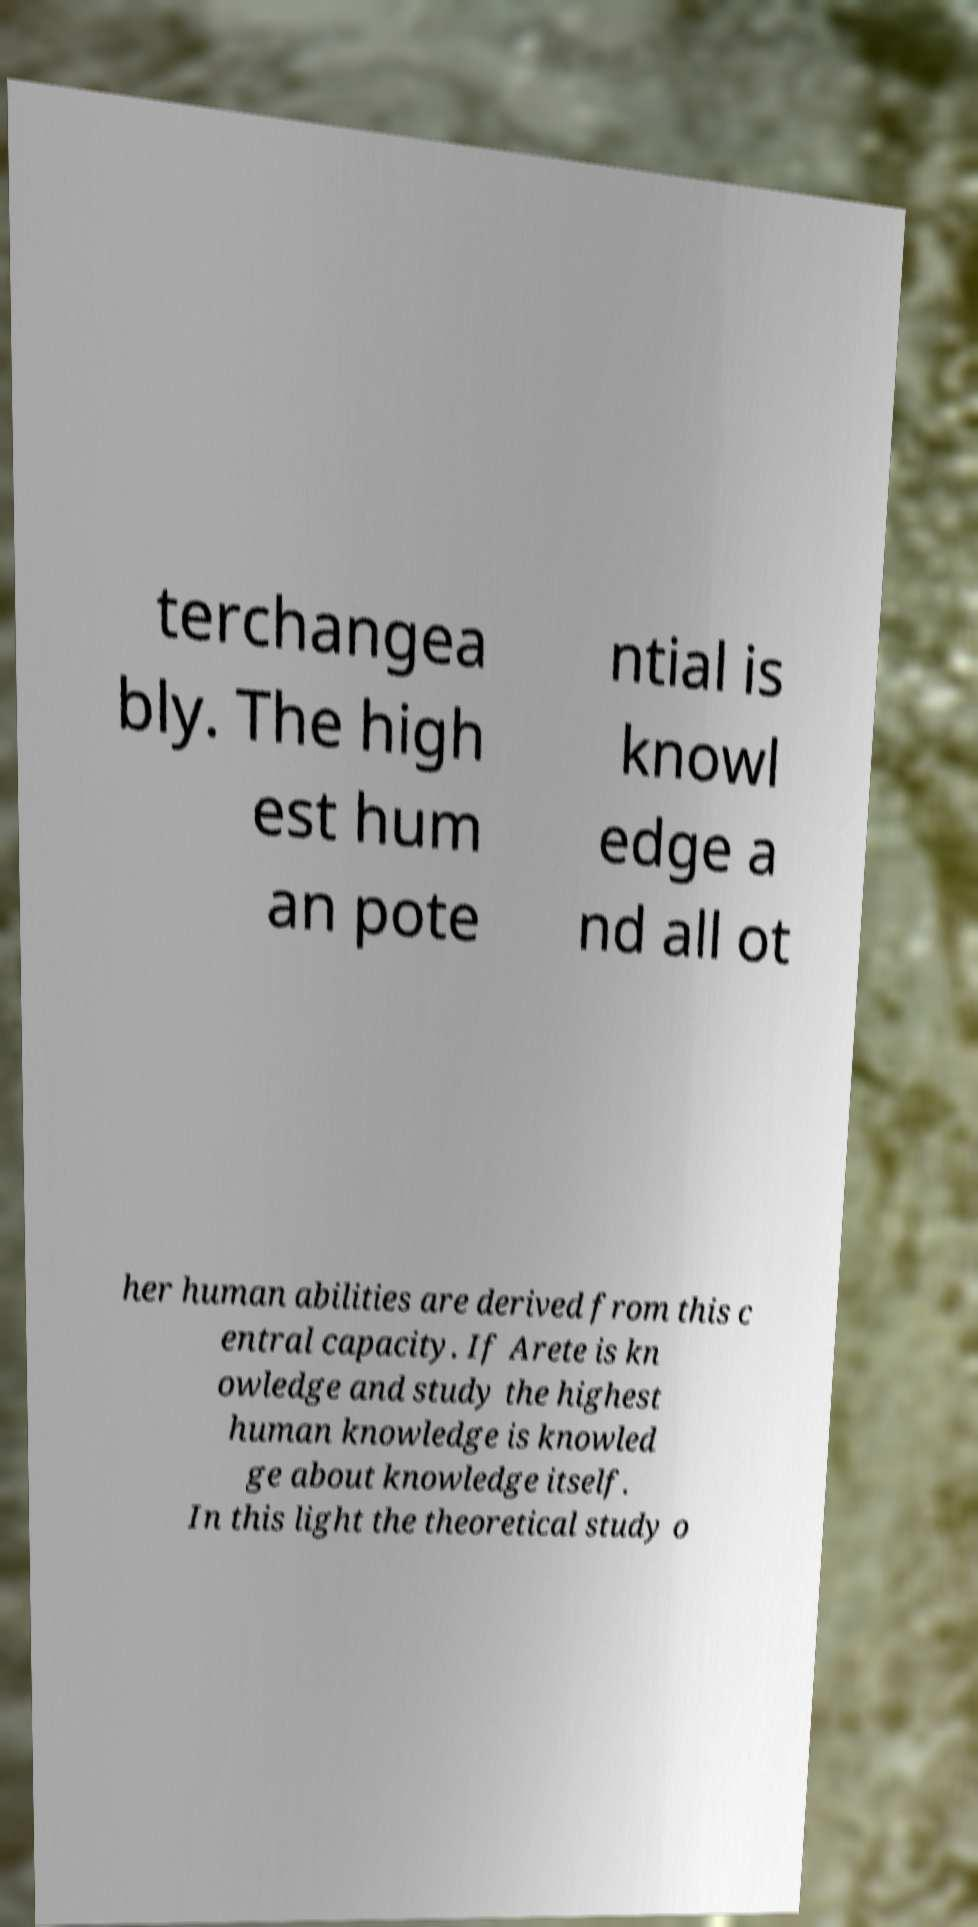Please identify and transcribe the text found in this image. terchangea bly. The high est hum an pote ntial is knowl edge a nd all ot her human abilities are derived from this c entral capacity. If Arete is kn owledge and study the highest human knowledge is knowled ge about knowledge itself. In this light the theoretical study o 